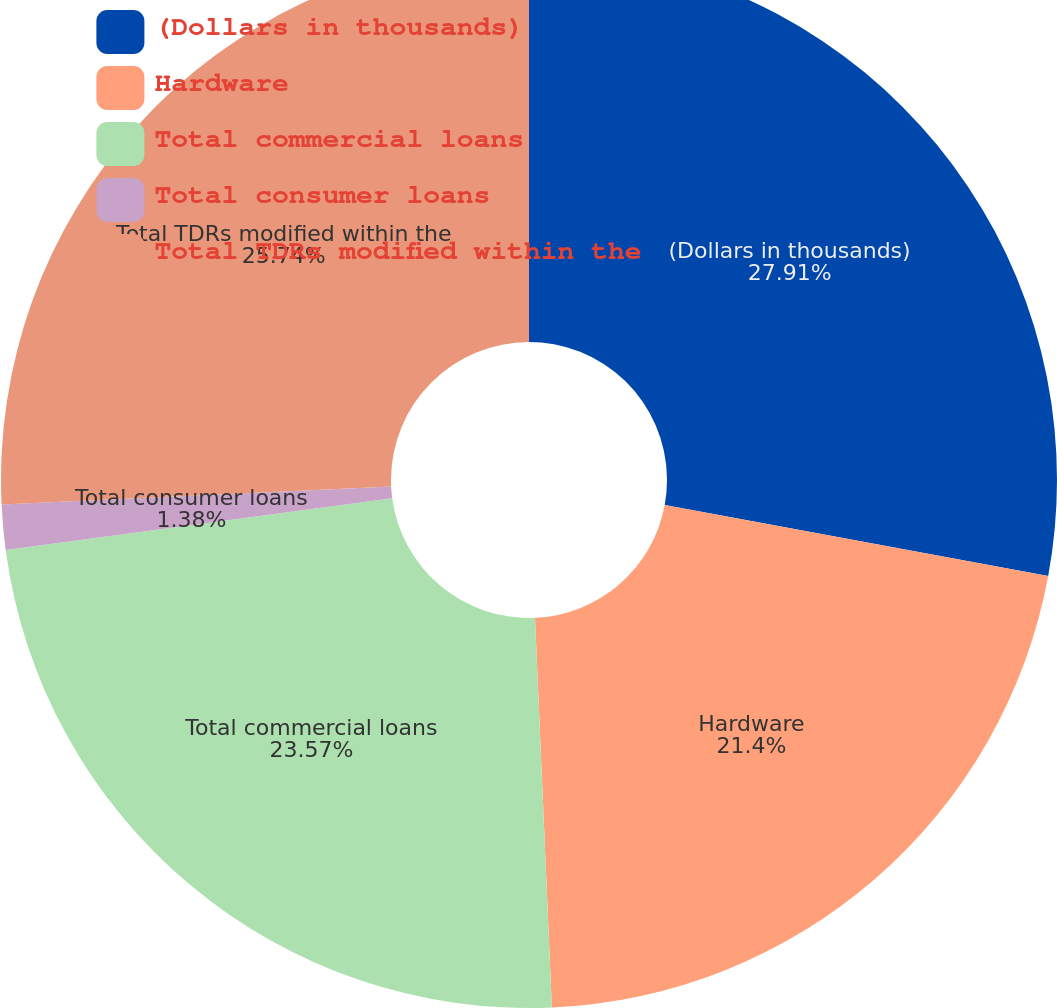Convert chart. <chart><loc_0><loc_0><loc_500><loc_500><pie_chart><fcel>(Dollars in thousands)<fcel>Hardware<fcel>Total commercial loans<fcel>Total consumer loans<fcel>Total TDRs modified within the<nl><fcel>27.91%<fcel>21.4%<fcel>23.57%<fcel>1.38%<fcel>25.74%<nl></chart> 